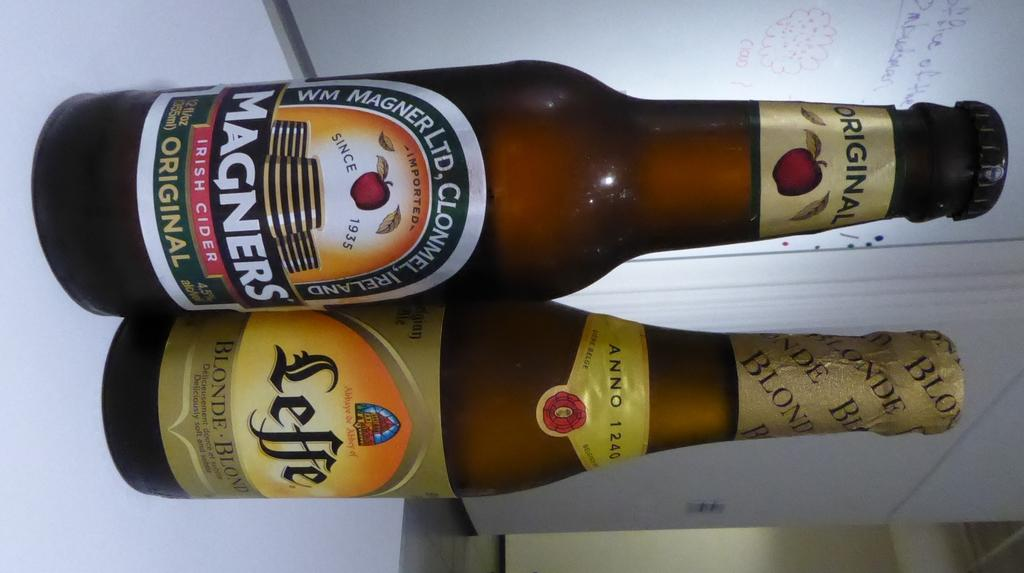Provide a one-sentence caption for the provided image. One bottle of Magners Cider and one bottle of Leffe Blonde set on a white table. 